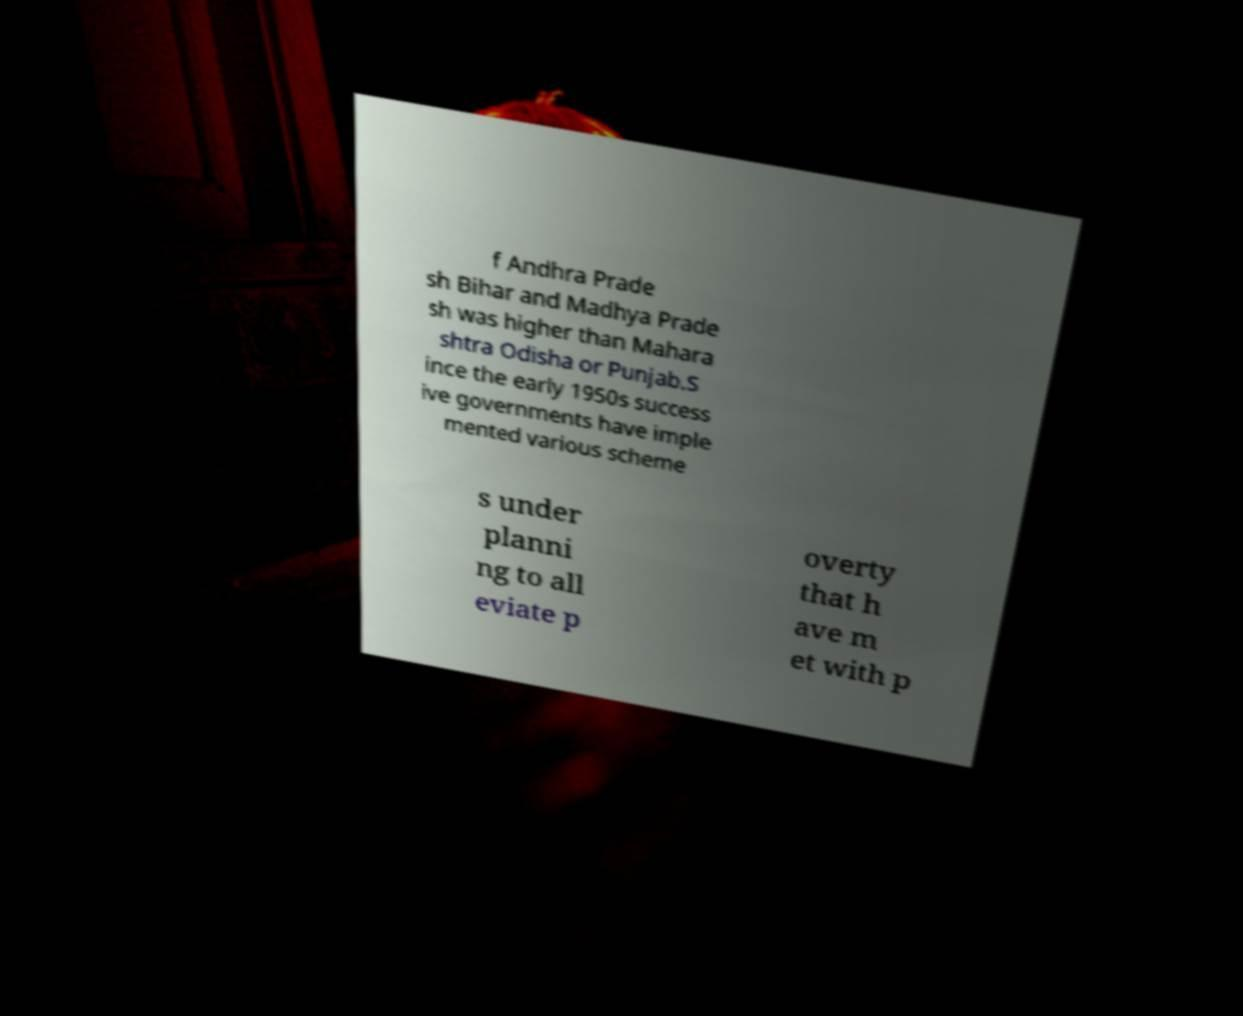Could you extract and type out the text from this image? f Andhra Prade sh Bihar and Madhya Prade sh was higher than Mahara shtra Odisha or Punjab.S ince the early 1950s success ive governments have imple mented various scheme s under planni ng to all eviate p overty that h ave m et with p 